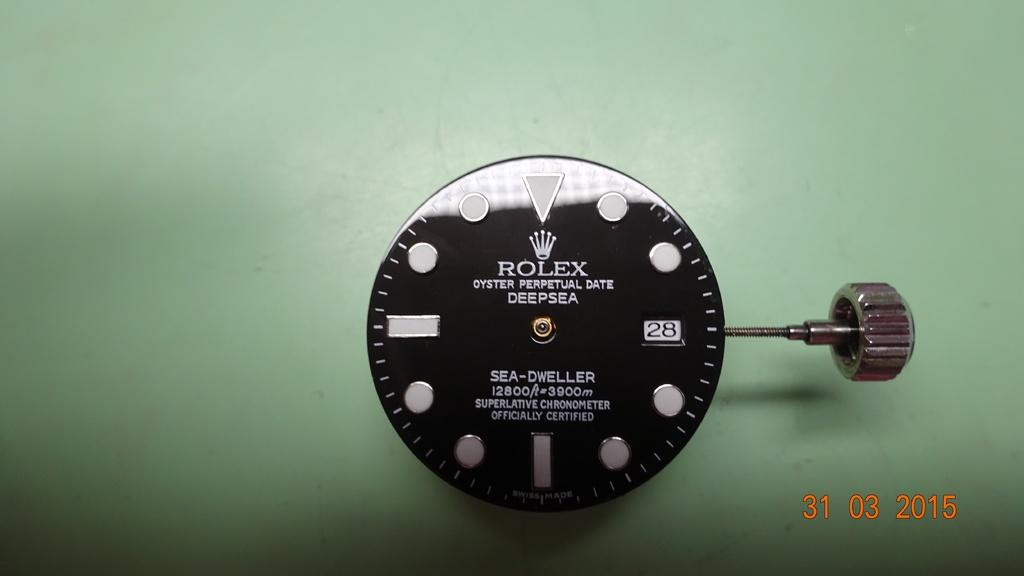What can be seen in the image related to timekeeping? There is a watch dial in the image. What other object is present in the image? There is a knob in the image. Where is the cactus located in the image? There is no cactus present in the image. What type of jewelry is shown in the image? There is no jewelry, such as a locket, present in the image. 